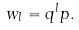<formula> <loc_0><loc_0><loc_500><loc_500>w _ { l } = q ^ { l } p .</formula> 